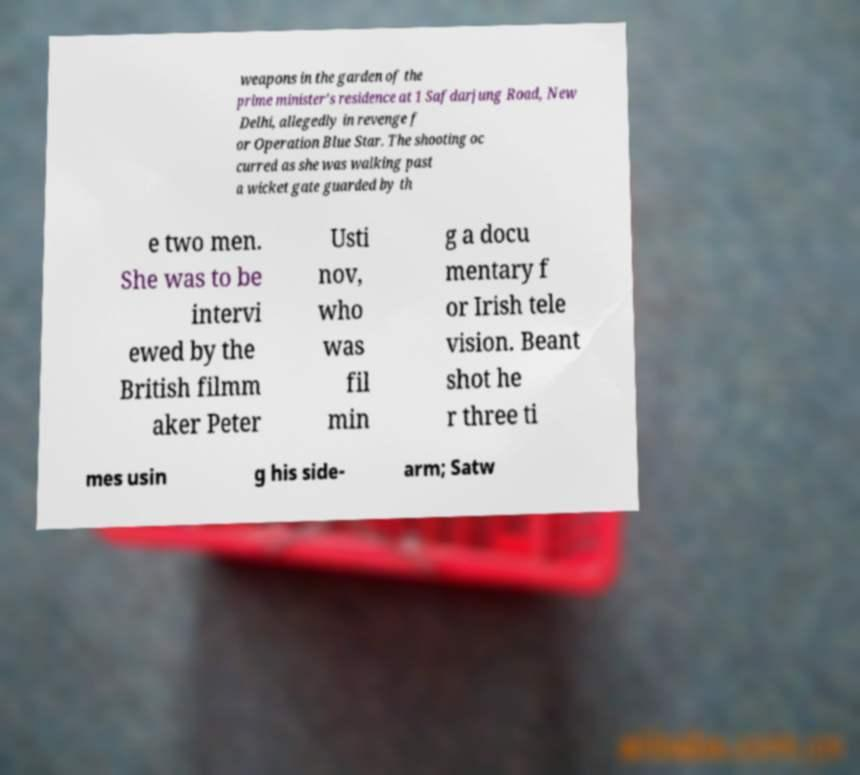What messages or text are displayed in this image? I need them in a readable, typed format. weapons in the garden of the prime minister's residence at 1 Safdarjung Road, New Delhi, allegedly in revenge f or Operation Blue Star. The shooting oc curred as she was walking past a wicket gate guarded by th e two men. She was to be intervi ewed by the British filmm aker Peter Usti nov, who was fil min g a docu mentary f or Irish tele vision. Beant shot he r three ti mes usin g his side- arm; Satw 